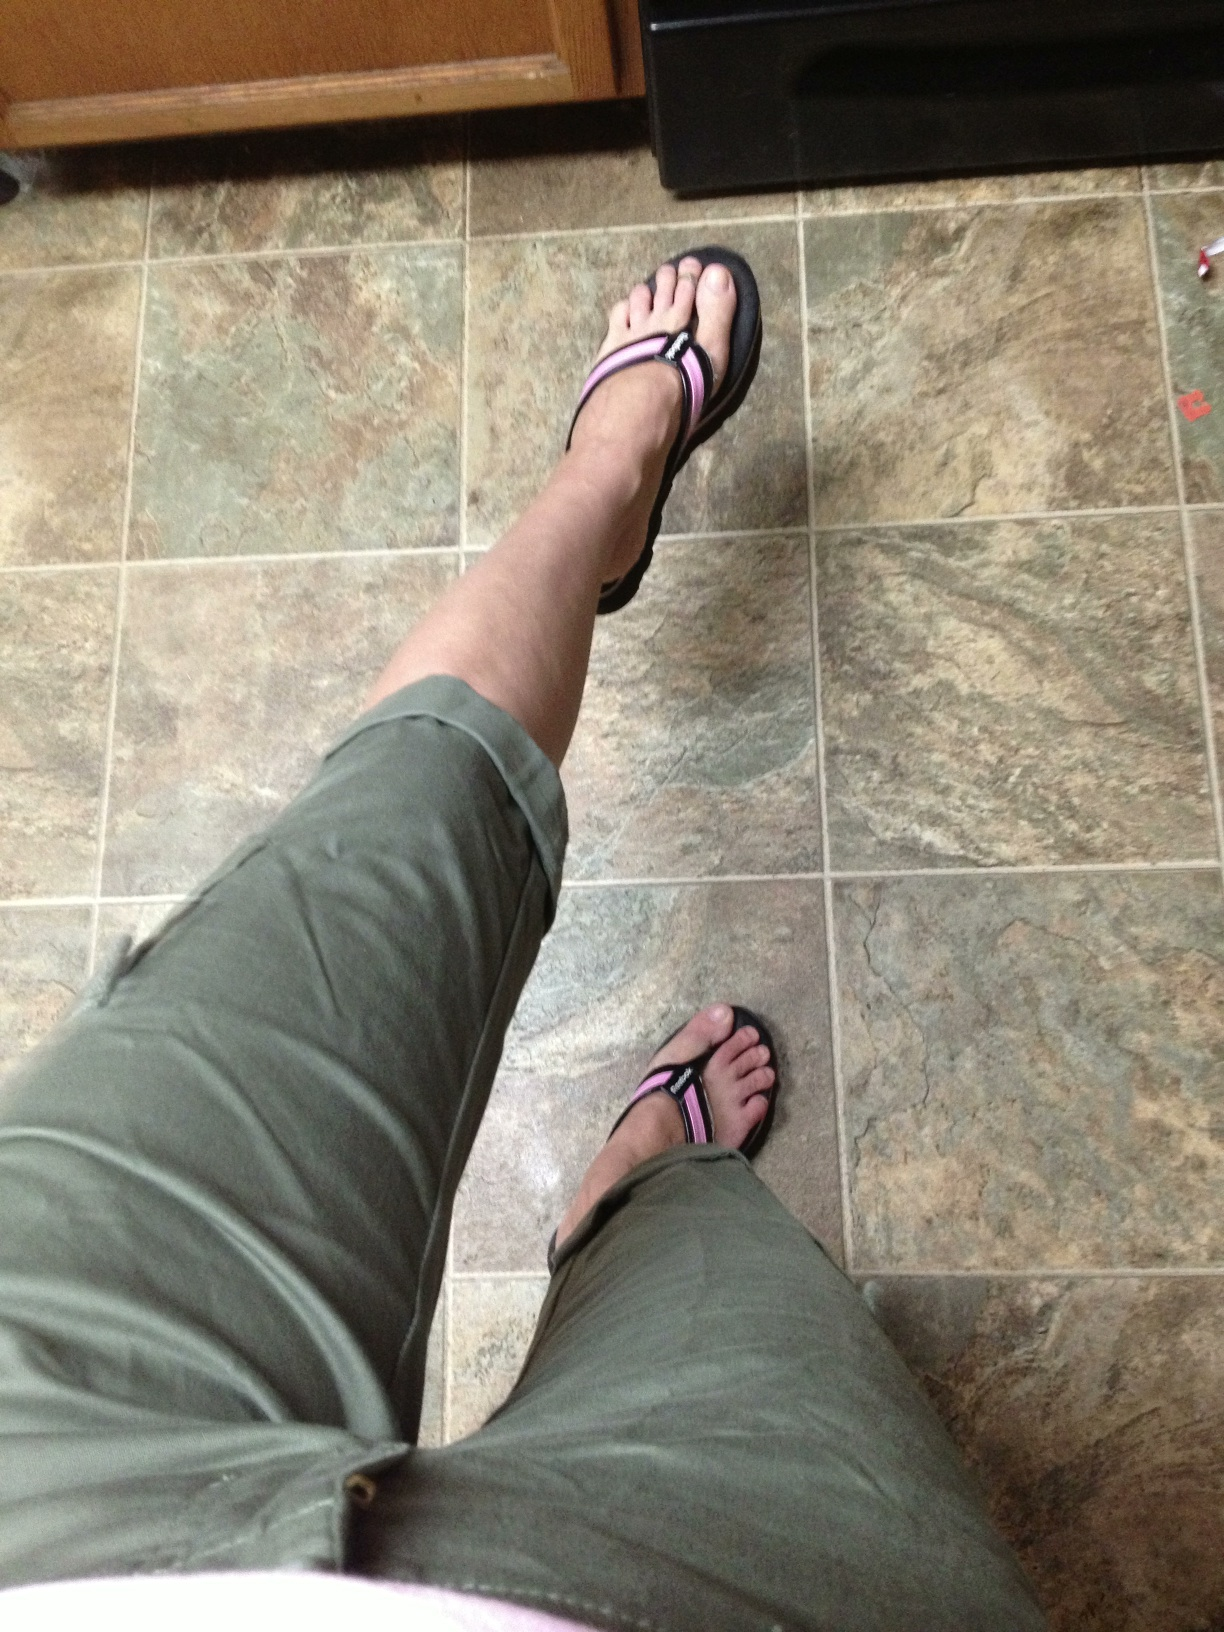Can you comment on the flooring visible in the image? The flooring in the image is tiled, featuring large square tiles with natural stone coloring and patterns. Such a design often suggests a durable, easy-to-clean surface, typical for areas like kitchens or bathrooms. 